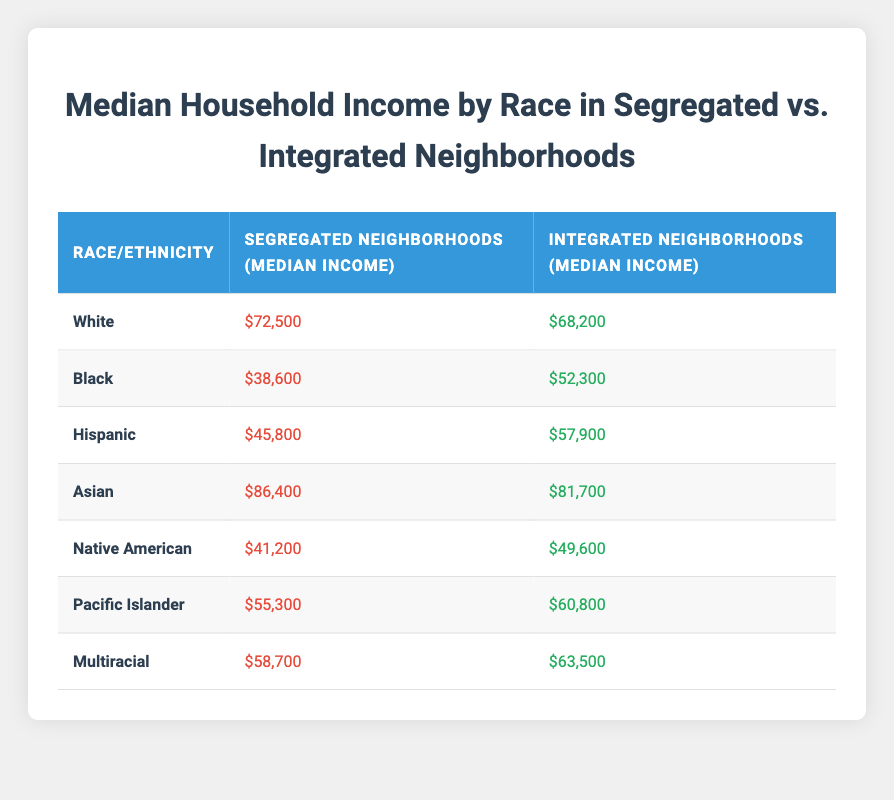What is the median income for Black households in segregated neighborhoods? According to the table, the median income for Black households in segregated neighborhoods is listed directly. Therefore, the answer can be found in the corresponding row under the "Segregated Neighborhoods" column for Black.
Answer: $38,600 What is the difference in median income for Asian households between integrated and segregated neighborhoods? To find the difference, we subtract the median income of Asian households in integrated neighborhoods from the median income in segregated neighborhoods. This is calculated as follows: $86,400 (segregated) - $81,700 (integrated) = $4,700.
Answer: $4,700 Is the median income for Hispanic households higher in integrated neighborhoods than in segregated neighborhoods? By comparing the values in the table, the median income for Hispanic households in integrated neighborhoods ($57,900) is greater than that in segregated neighborhoods ($45,800). Therefore, the statement is true.
Answer: Yes Which racial/ethnic group has the highest median income in segregated neighborhoods? Looking through the "Segregated Neighborhoods" column, we find that the Asian households have the highest median income at $86,400. This is the maximum value in that specific column.
Answer: Asian What is the average median income of Black and Native American households in integrated neighborhoods? To find the average, we first identify the median incomes for Black ($52,300) and Native American ($49,600) households in integrated neighborhoods. We sum these two values: $52,300 + $49,600 = $101,900. Then, we divide by 2 (the number of groups) to find the average: $101,900 / 2 = $50,950.
Answer: $50,950 Are Pacific Islander households in integrated neighborhoods earning more than the average income of White households in segregated neighborhoods? The median income for Pacific Islander households in integrated neighborhoods is $60,800, and the median income for White households in segregated neighborhoods is $72,500. Comparing these two values, $60,800 is less than $72,500, making the statement false.
Answer: No Which racial/ethnic group experiences the smallest difference in median income between integrated and segregated neighborhoods? We can calculate the differences for each group by subtracting the integrated median income from the segregated median income, noting the smallest result. For example: Black = $38,600 - $52,300 = -$13,700; Hispanic = $45,800 - $57,900 = -$12,100; Asian = $86,400 - $81,700 = $4,700; Native American = $41,200 - $49,600 = -$8,400; Pacific Islander = $55,300 - $60,800 = -$5,500; Multiracial = $58,700 - $63,500 = -$4,800. The smallest absolute difference is for Multiracial with $4,800.
Answer: Multiracial What is the total median income of White and Hispanic households in segregated neighborhoods? To get the total, we add the median incomes for White ($72,500) and Hispanic ($45,800) in segregated neighborhoods. This gives us: $72,500 + $45,800 = $118,300.
Answer: $118,300 